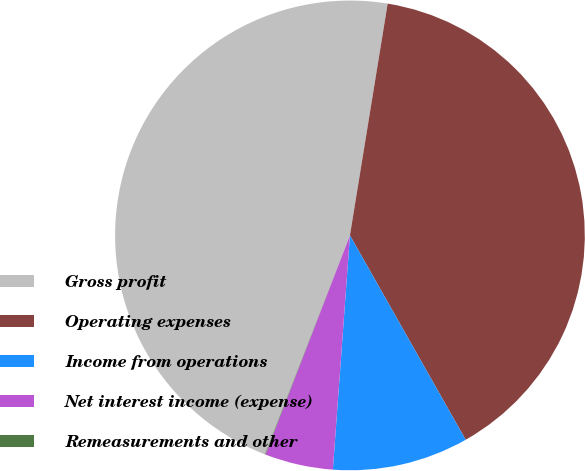Convert chart to OTSL. <chart><loc_0><loc_0><loc_500><loc_500><pie_chart><fcel>Gross profit<fcel>Operating expenses<fcel>Income from operations<fcel>Net interest income (expense)<fcel>Remeasurements and other<nl><fcel>46.67%<fcel>39.23%<fcel>9.36%<fcel>4.7%<fcel>0.04%<nl></chart> 